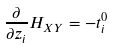Convert formula to latex. <formula><loc_0><loc_0><loc_500><loc_500>\frac { \partial } { \partial z _ { i } } H _ { X Y } = - t ^ { 0 } _ { i }</formula> 